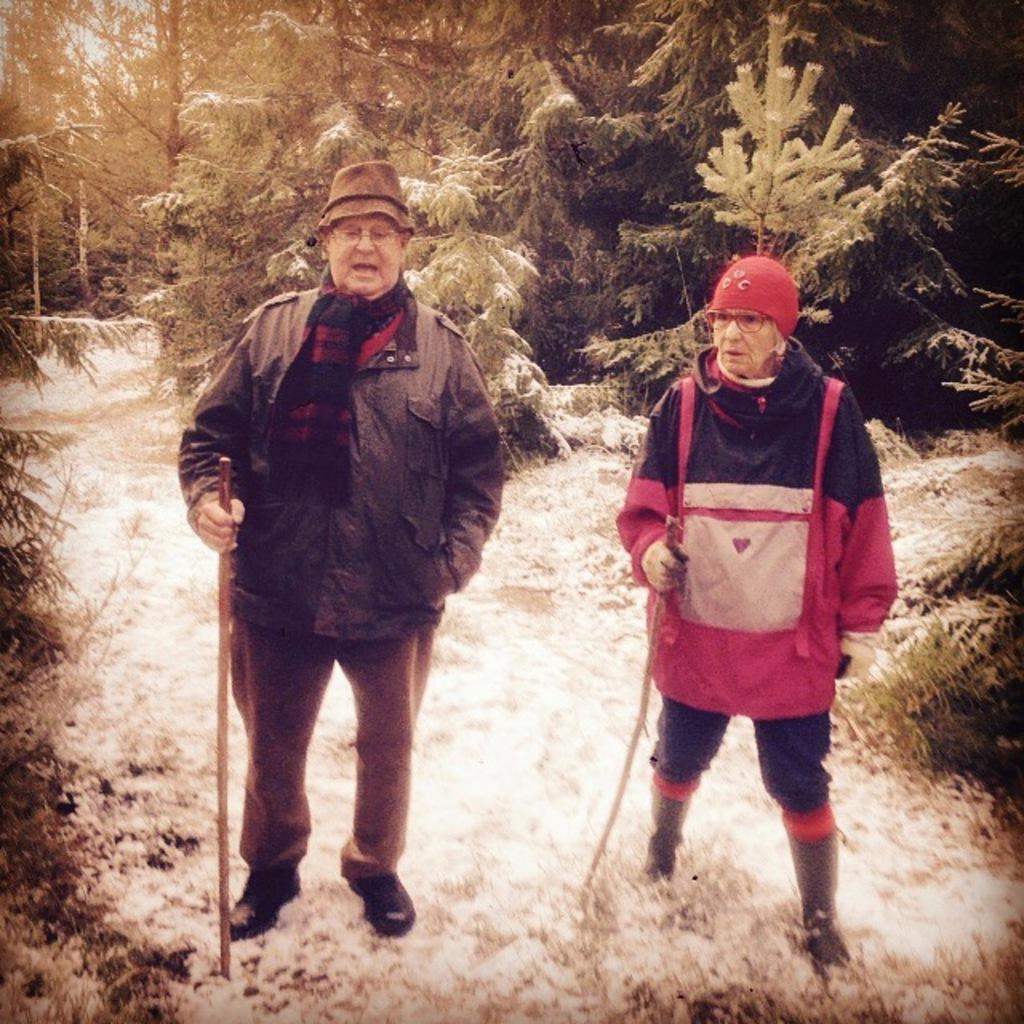How many people are in the image? There are two persons in the image. What are the persons doing in the image? The persons are standing and holding a stick in their hands. What can be seen in the background of the image? There are trees in the background of the image. What is the condition of the trees in the image? The trees are covered with snow. What type of organization is represented by the cup in the image? There is no cup present in the image, so it cannot be used to represent any organization. What joke can be seen on the stick that the persons are holding? There is no joke visible on the stick; it is simply a stick being held by the persons. 